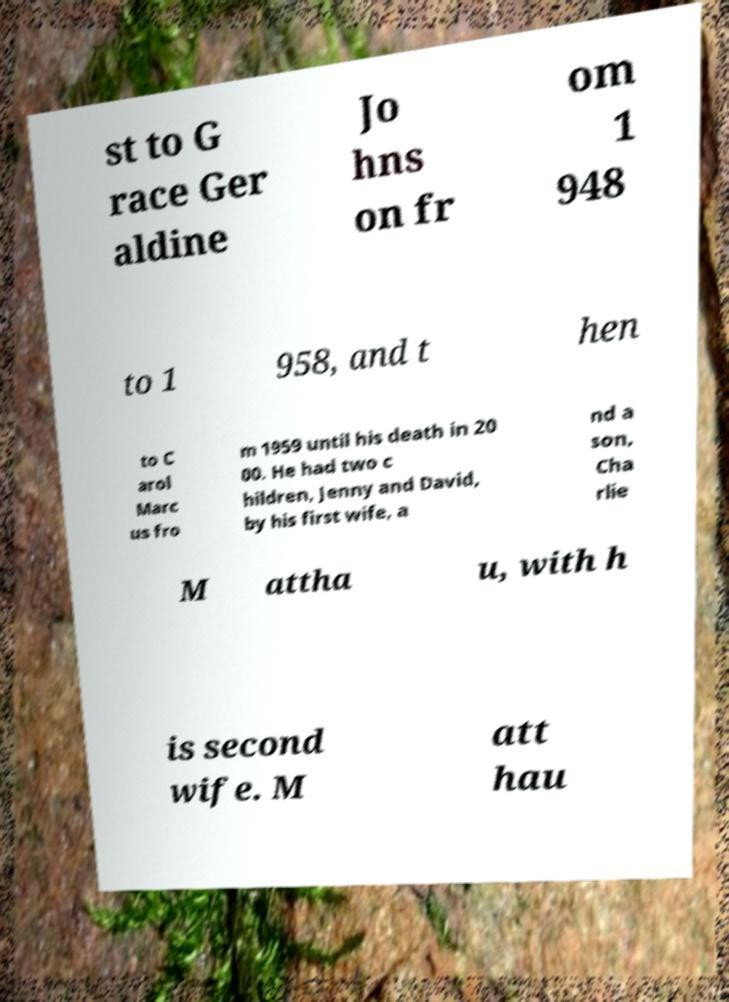There's text embedded in this image that I need extracted. Can you transcribe it verbatim? st to G race Ger aldine Jo hns on fr om 1 948 to 1 958, and t hen to C arol Marc us fro m 1959 until his death in 20 00. He had two c hildren, Jenny and David, by his first wife, a nd a son, Cha rlie M attha u, with h is second wife. M att hau 